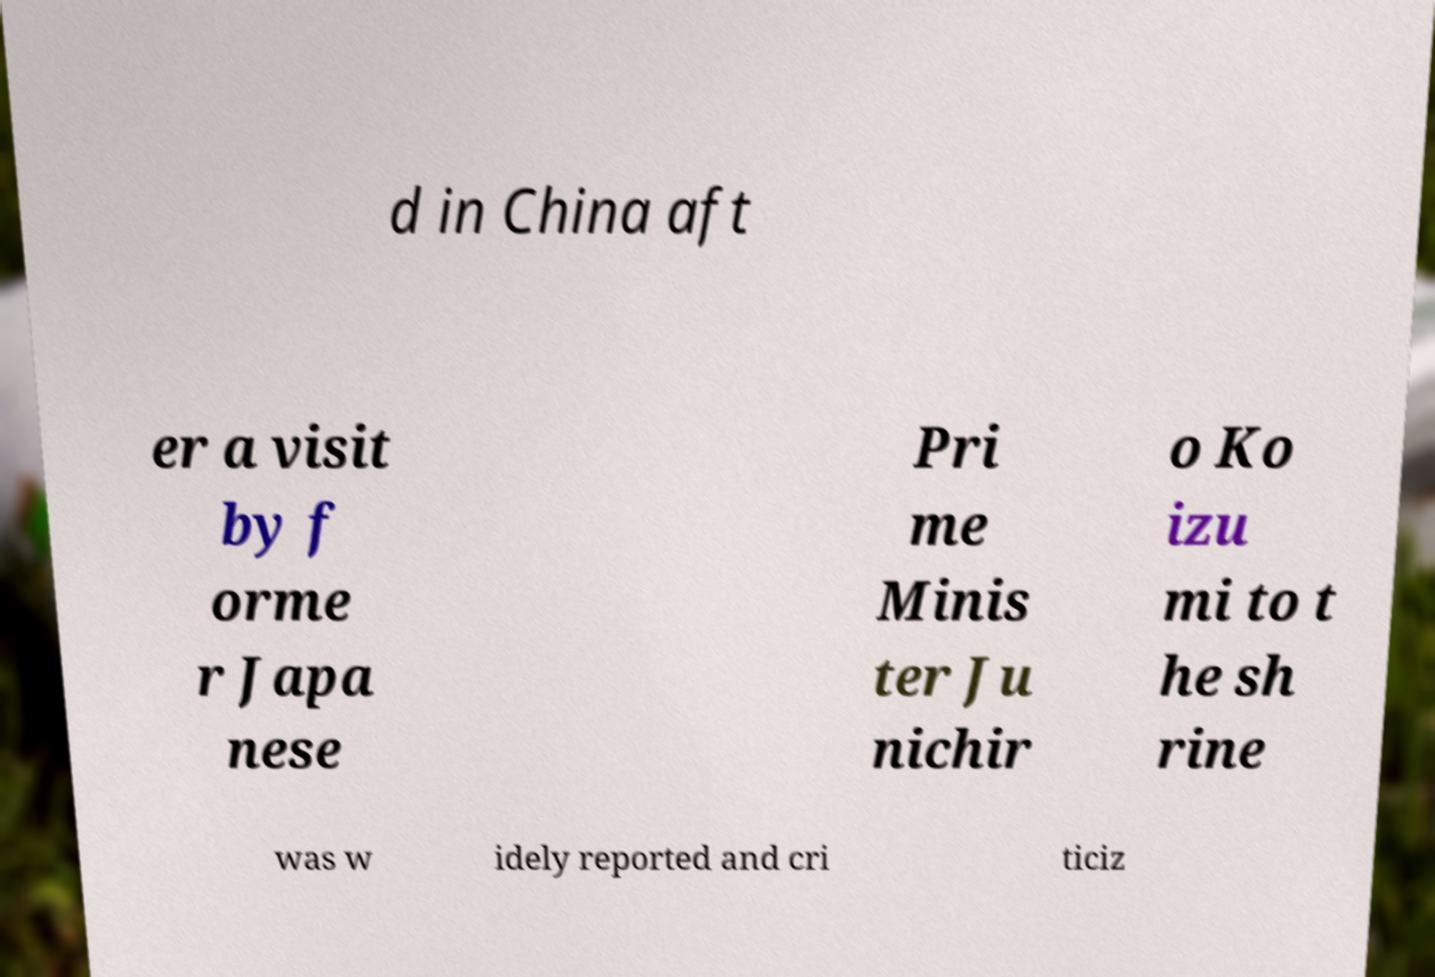Could you assist in decoding the text presented in this image and type it out clearly? d in China aft er a visit by f orme r Japa nese Pri me Minis ter Ju nichir o Ko izu mi to t he sh rine was w idely reported and cri ticiz 